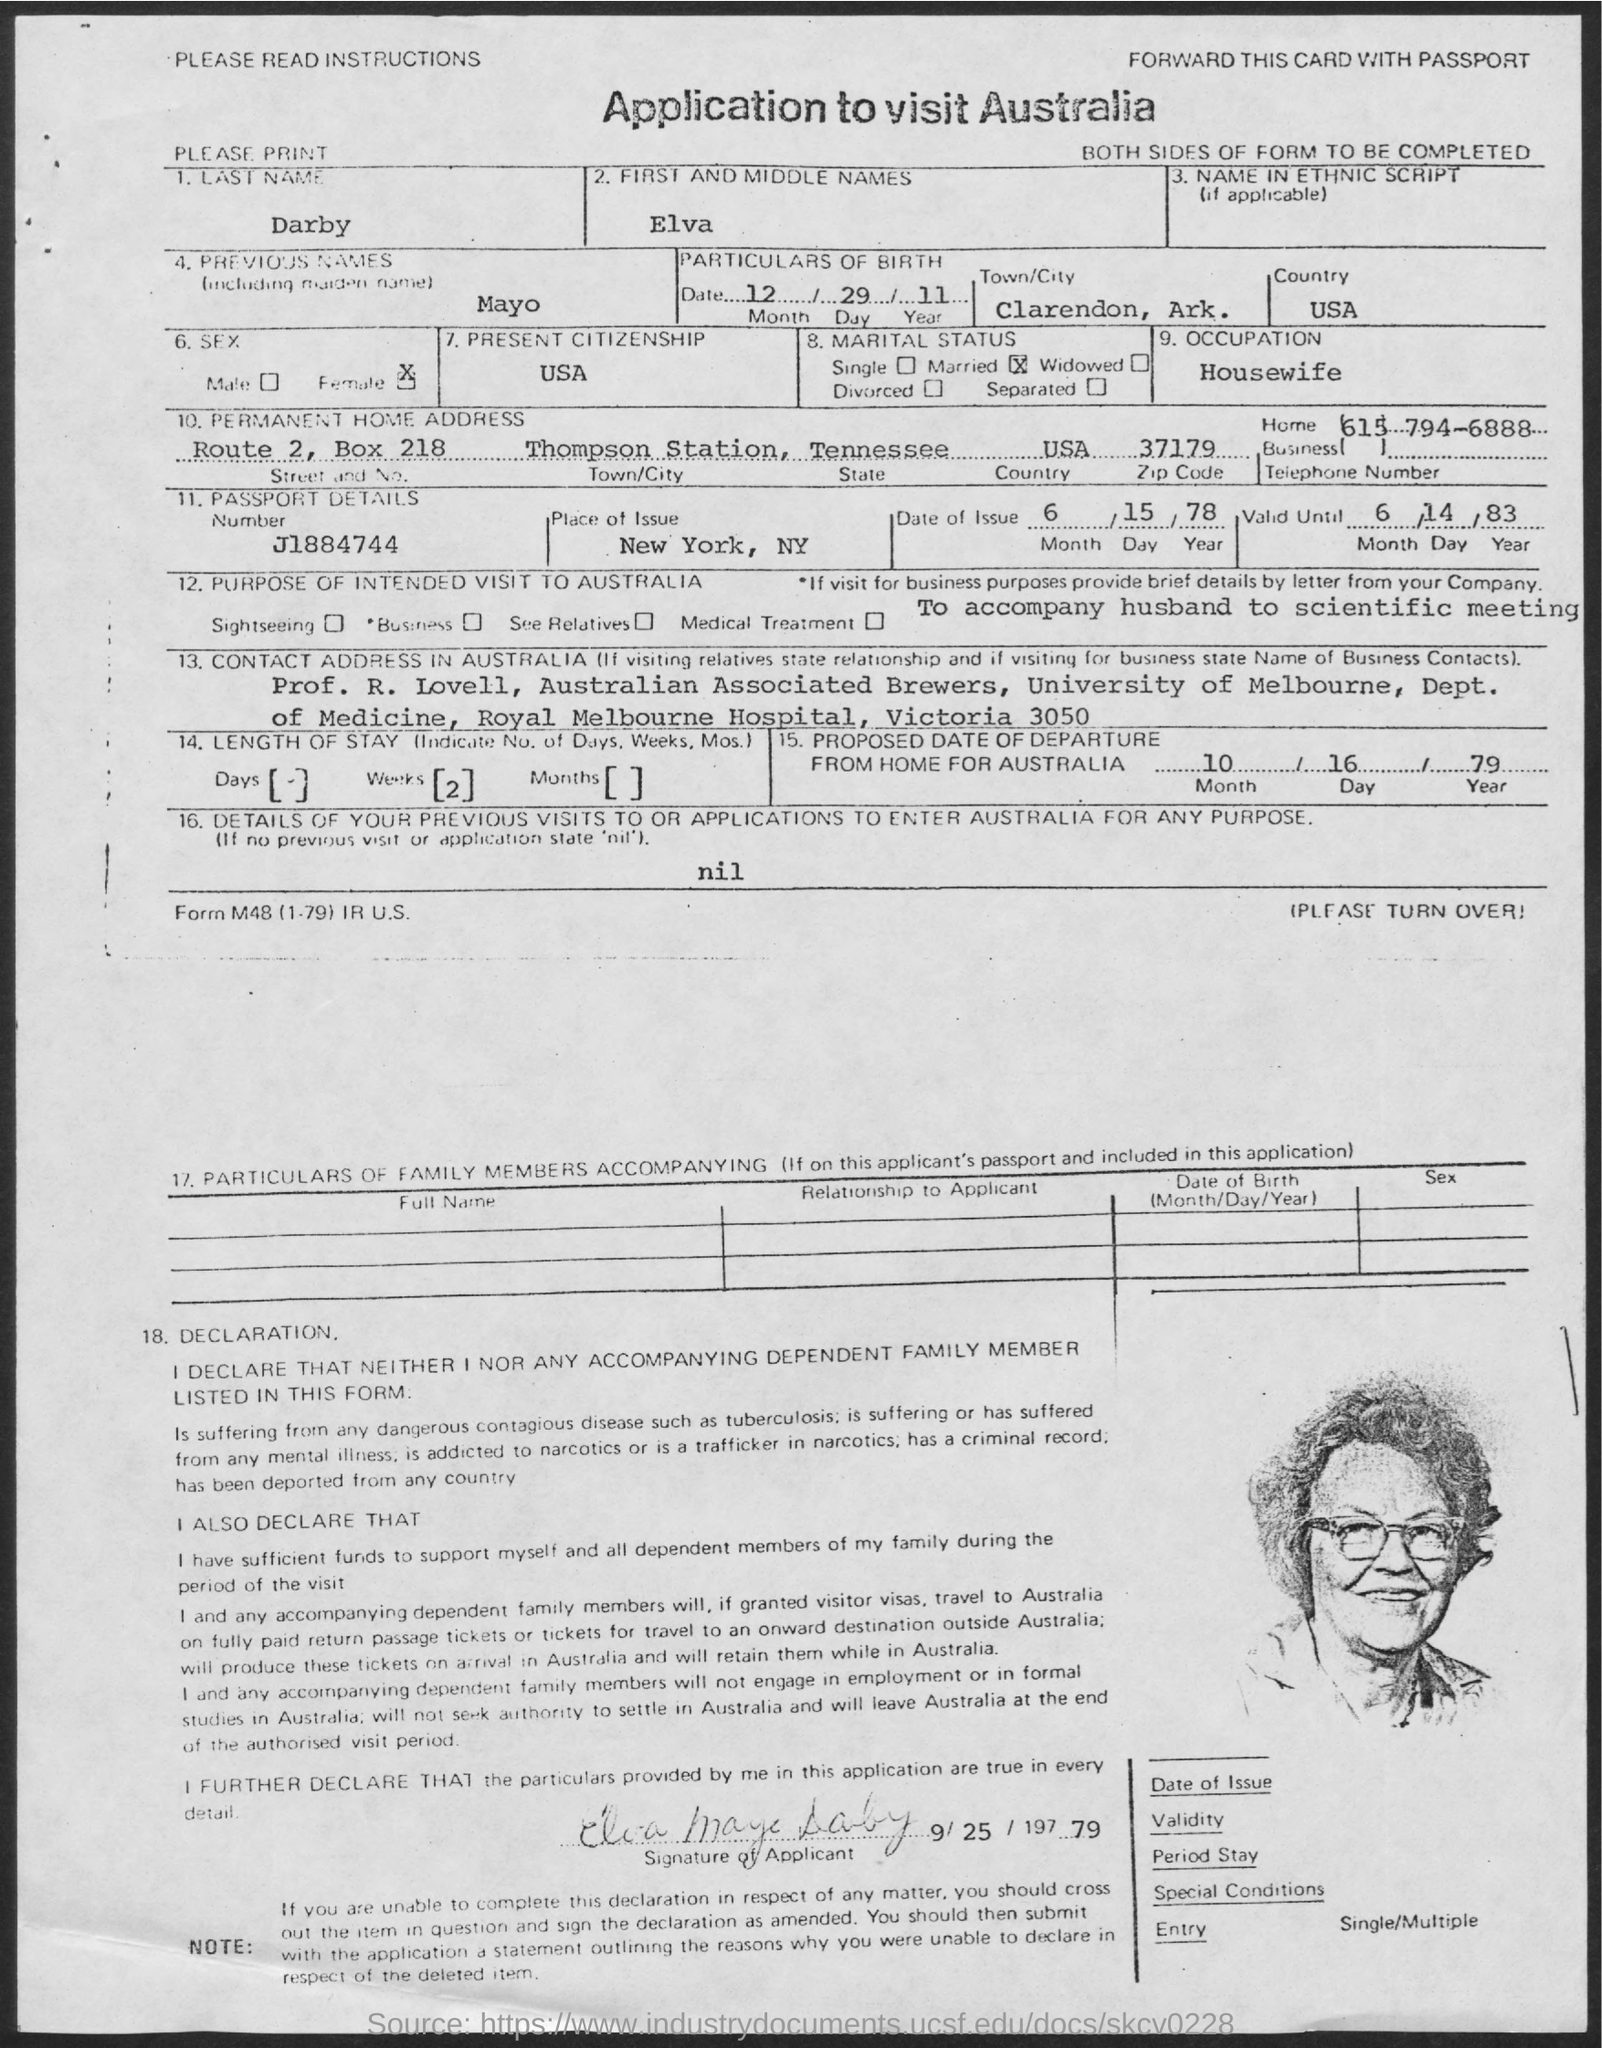What is the Last name of Applicant ?
Ensure brevity in your answer.  Darby. What is the Passport Details Number ?
Provide a short and direct response. J1884744. What is the Birth Date ?
Your response must be concise. 12/29/11. What is the Occupation of Elva ?
Ensure brevity in your answer.  Housewife. What is the Box Number ?
Your answer should be very brief. Box 218. 